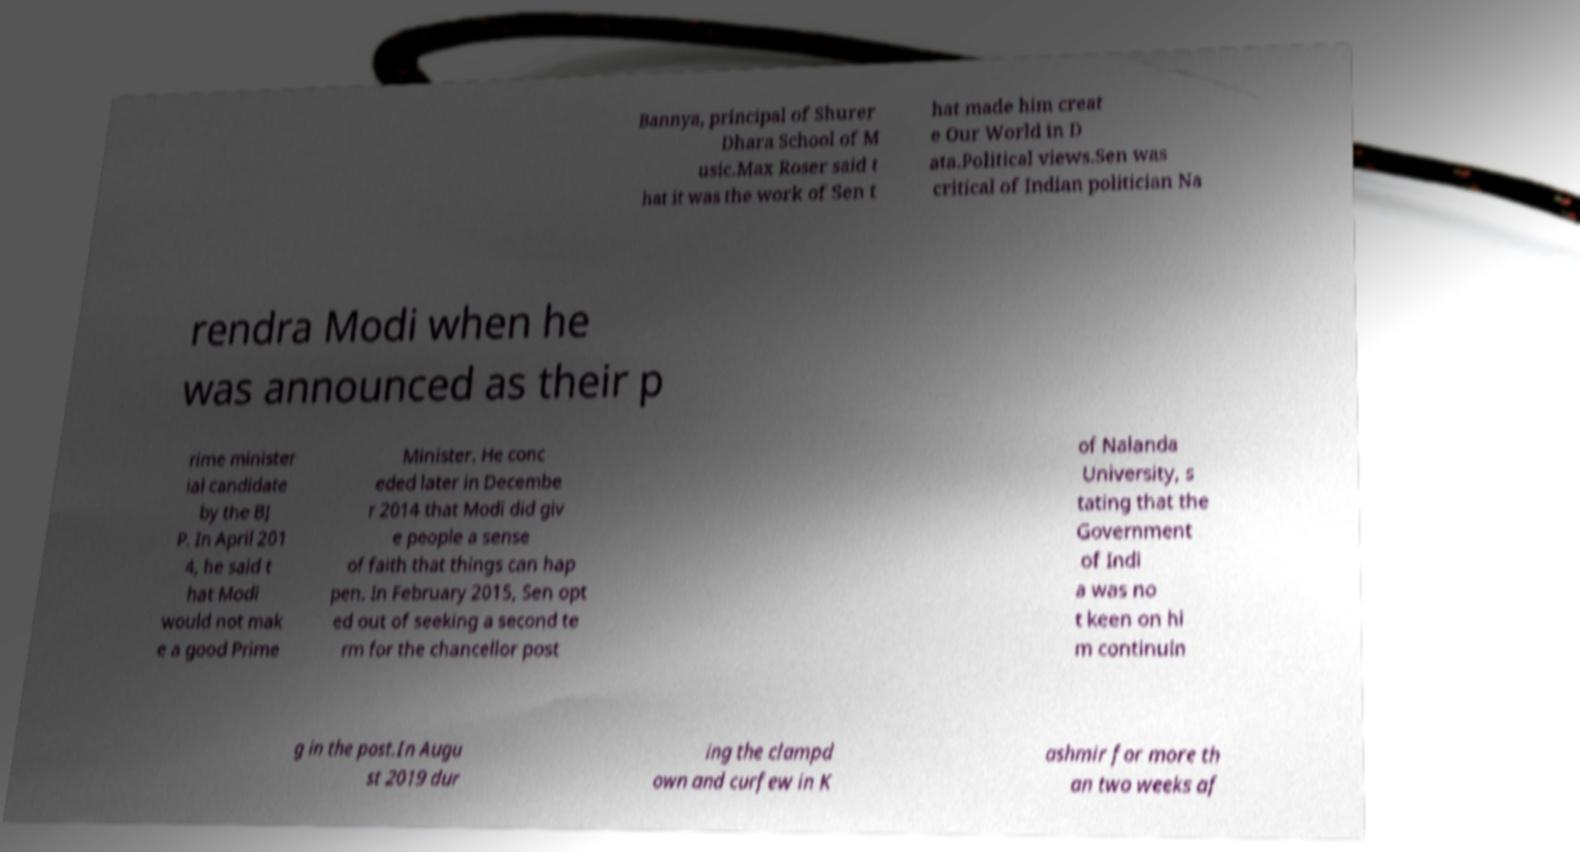Please identify and transcribe the text found in this image. Bannya, principal of Shurer Dhara School of M usic.Max Roser said t hat it was the work of Sen t hat made him creat e Our World in D ata.Political views.Sen was critical of Indian politician Na rendra Modi when he was announced as their p rime minister ial candidate by the BJ P. In April 201 4, he said t hat Modi would not mak e a good Prime Minister. He conc eded later in Decembe r 2014 that Modi did giv e people a sense of faith that things can hap pen. In February 2015, Sen opt ed out of seeking a second te rm for the chancellor post of Nalanda University, s tating that the Government of Indi a was no t keen on hi m continuin g in the post.In Augu st 2019 dur ing the clampd own and curfew in K ashmir for more th an two weeks af 